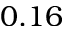Convert formula to latex. <formula><loc_0><loc_0><loc_500><loc_500>0 . 1 6</formula> 